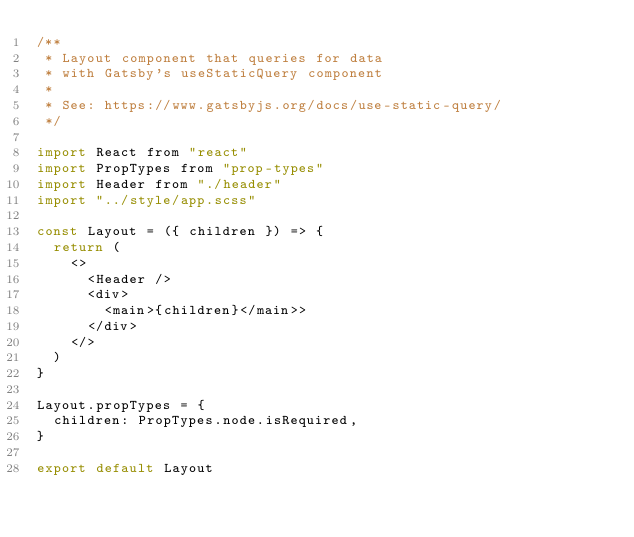Convert code to text. <code><loc_0><loc_0><loc_500><loc_500><_JavaScript_>/**
 * Layout component that queries for data
 * with Gatsby's useStaticQuery component
 *
 * See: https://www.gatsbyjs.org/docs/use-static-query/
 */

import React from "react"
import PropTypes from "prop-types"
import Header from "./header"
import "../style/app.scss"

const Layout = ({ children }) => {
  return (
    <>
      <Header />
      <div>
        <main>{children}</main>>
      </div>
    </>
  )
}

Layout.propTypes = {
  children: PropTypes.node.isRequired,
}

export default Layout
</code> 